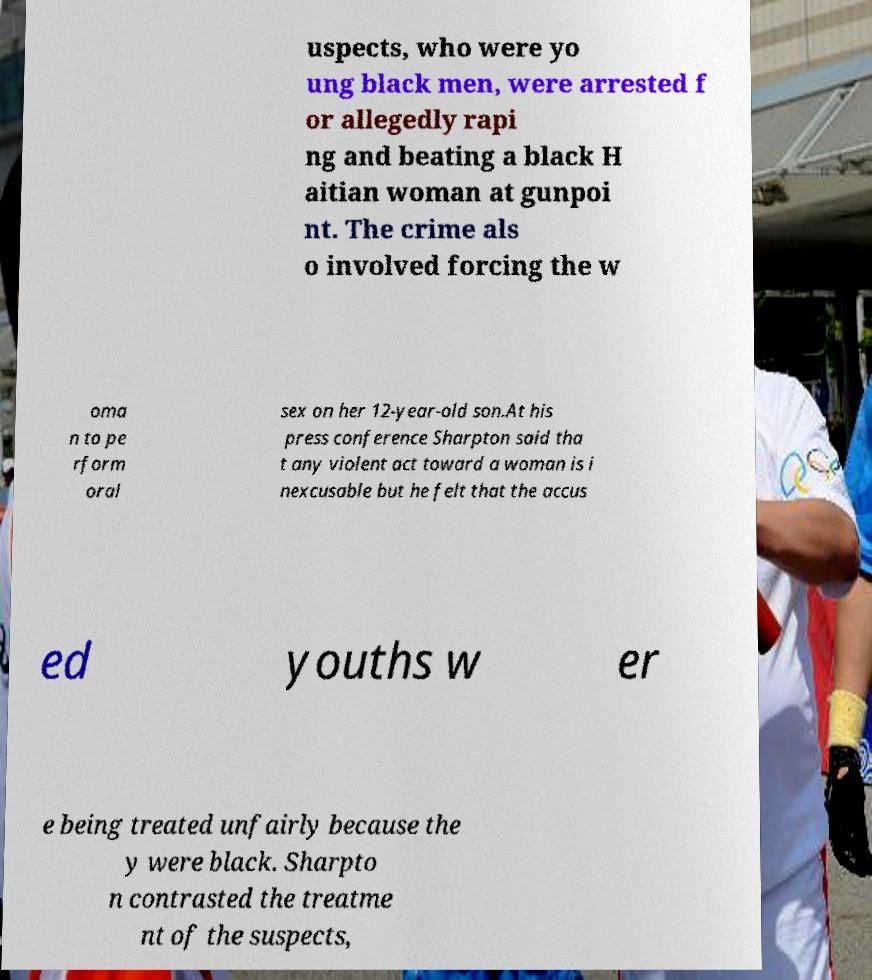What messages or text are displayed in this image? I need them in a readable, typed format. uspects, who were yo ung black men, were arrested f or allegedly rapi ng and beating a black H aitian woman at gunpoi nt. The crime als o involved forcing the w oma n to pe rform oral sex on her 12-year-old son.At his press conference Sharpton said tha t any violent act toward a woman is i nexcusable but he felt that the accus ed youths w er e being treated unfairly because the y were black. Sharpto n contrasted the treatme nt of the suspects, 